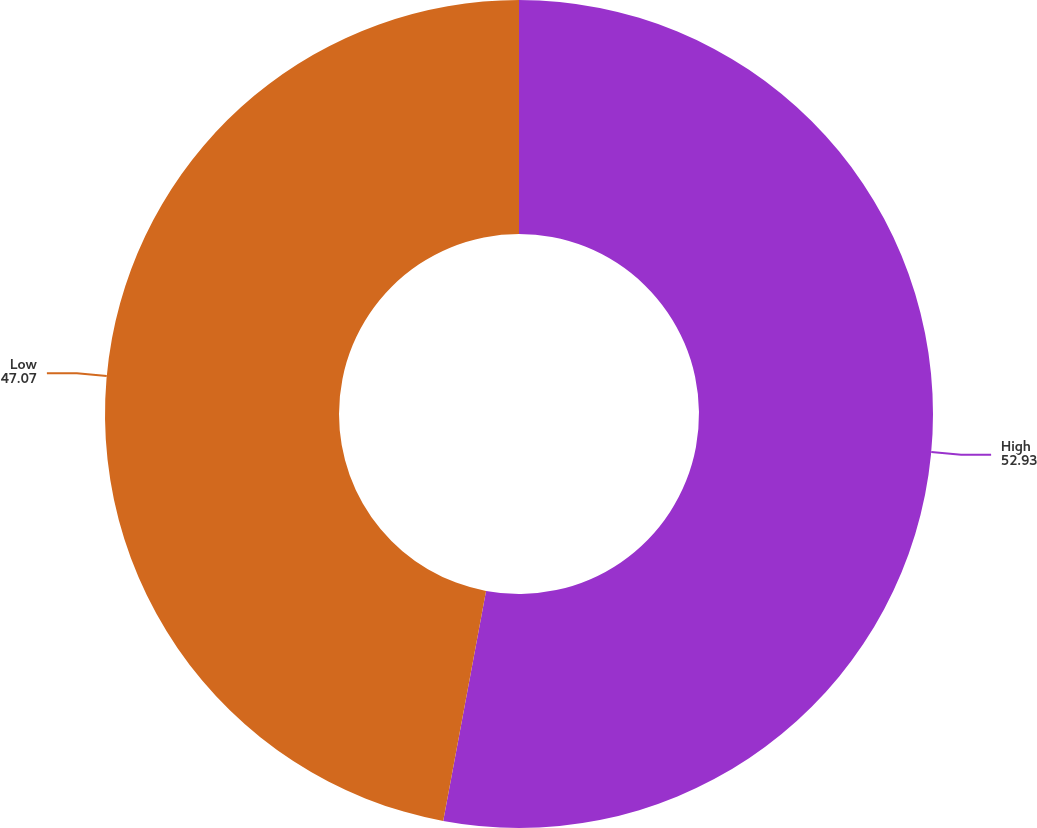Convert chart. <chart><loc_0><loc_0><loc_500><loc_500><pie_chart><fcel>High<fcel>Low<nl><fcel>52.93%<fcel>47.07%<nl></chart> 